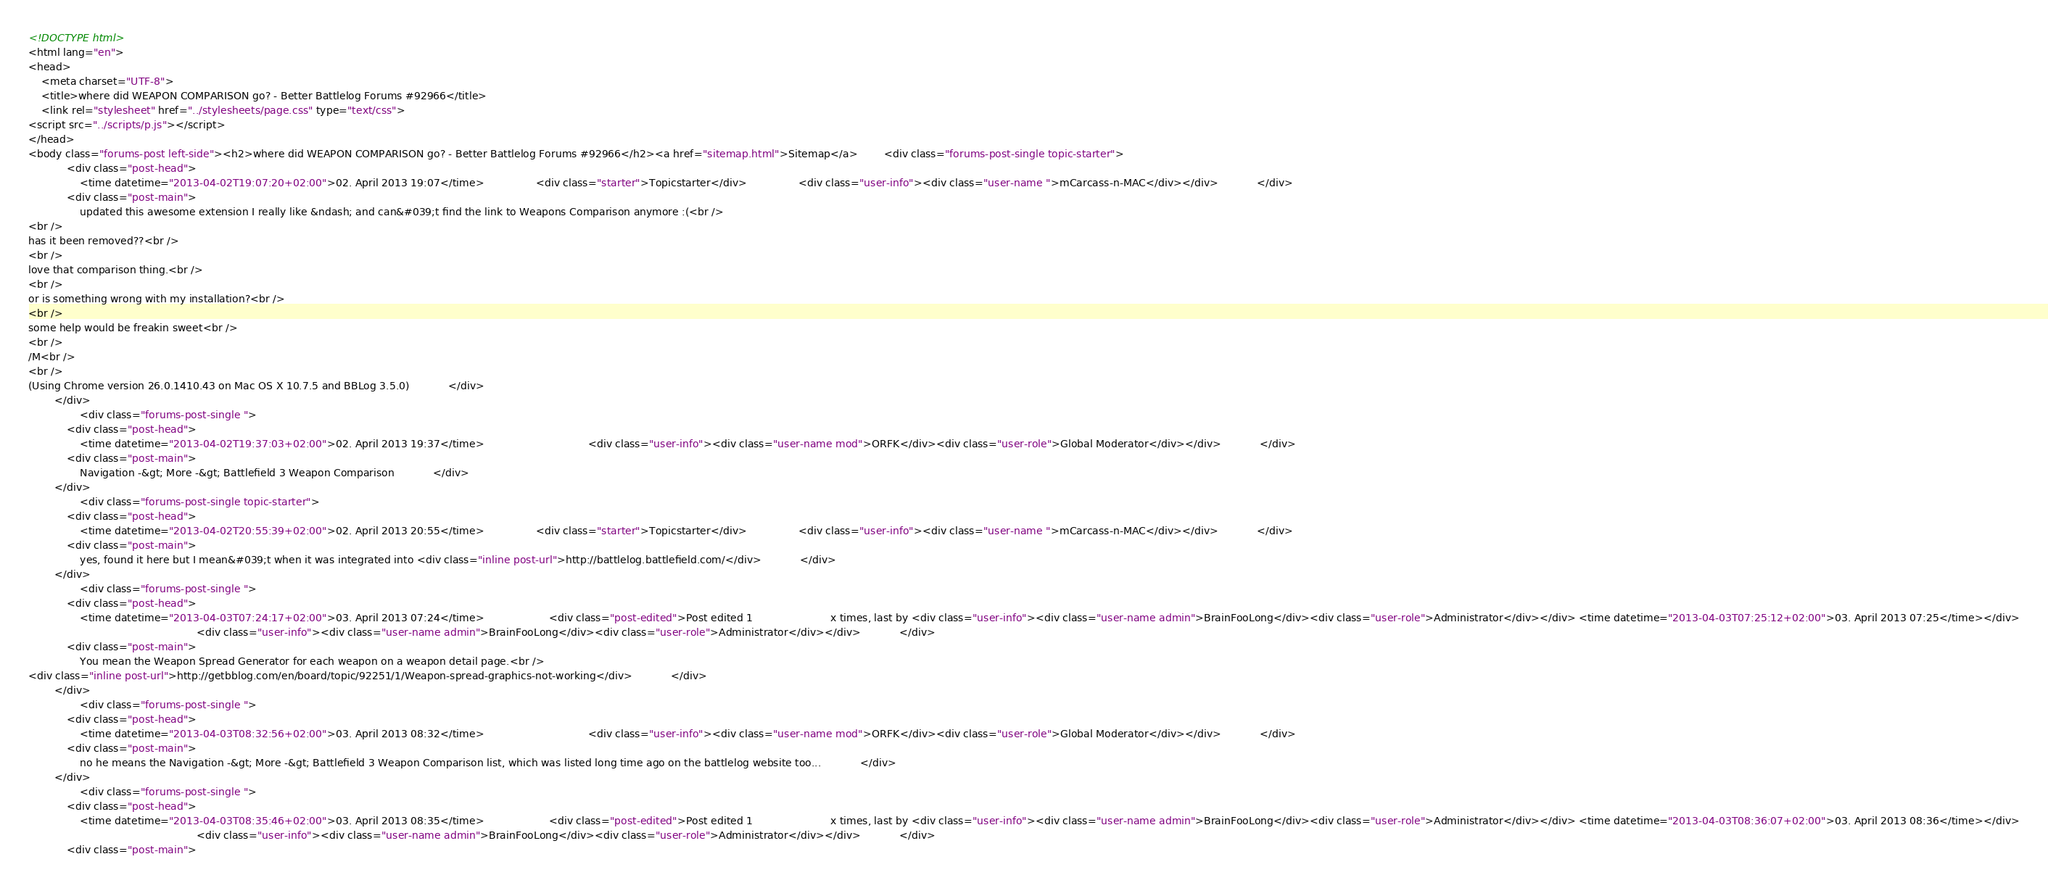Convert code to text. <code><loc_0><loc_0><loc_500><loc_500><_HTML_><!DOCTYPE html>
<html lang="en">
<head>
    <meta charset="UTF-8">
    <title>where did WEAPON COMPARISON go? - Better Battlelog Forums #92966</title>
    <link rel="stylesheet" href="../stylesheets/page.css" type="text/css">
<script src="../scripts/p.js"></script>
</head>
<body class="forums-post left-side"><h2>where did WEAPON COMPARISON go? - Better Battlelog Forums #92966</h2><a href="sitemap.html">Sitemap</a>        <div class="forums-post-single topic-starter">
            <div class="post-head">
                <time datetime="2013-04-02T19:07:20+02:00">02. April 2013 19:07</time>                <div class="starter">Topicstarter</div>                <div class="user-info"><div class="user-name ">mCarcass-n-MAC</div></div>            </div>
            <div class="post-main">
                updated this awesome extension I really like &ndash; and can&#039;t find the link to Weapons Comparison anymore :(<br />
<br />
has it been removed??<br />
<br />
love that comparison thing.<br />
<br />
or is something wrong with my installation?<br />
<br />
some help would be freakin sweet<br />
<br />
/M<br />
<br />
(Using Chrome version 26.0.1410.43 on Mac OS X 10.7.5 and BBLog 3.5.0)            </div>
        </div>
                <div class="forums-post-single ">
            <div class="post-head">
                <time datetime="2013-04-02T19:37:03+02:00">02. April 2013 19:37</time>                                <div class="user-info"><div class="user-name mod">ORFK</div><div class="user-role">Global Moderator</div></div>            </div>
            <div class="post-main">
                Navigation -&gt; More -&gt; Battlefield 3 Weapon Comparison            </div>
        </div>
                <div class="forums-post-single topic-starter">
            <div class="post-head">
                <time datetime="2013-04-02T20:55:39+02:00">02. April 2013 20:55</time>                <div class="starter">Topicstarter</div>                <div class="user-info"><div class="user-name ">mCarcass-n-MAC</div></div>            </div>
            <div class="post-main">
                yes, found it here but I mean&#039;t when it was integrated into <div class="inline post-url">http://battlelog.battlefield.com/</div>            </div>
        </div>
                <div class="forums-post-single ">
            <div class="post-head">
                <time datetime="2013-04-03T07:24:17+02:00">03. April 2013 07:24</time>                    <div class="post-edited">Post edited 1                        x times, last by <div class="user-info"><div class="user-name admin">BrainFooLong</div><div class="user-role">Administrator</div></div> <time datetime="2013-04-03T07:25:12+02:00">03. April 2013 07:25</time></div>
                                                    <div class="user-info"><div class="user-name admin">BrainFooLong</div><div class="user-role">Administrator</div></div>            </div>
            <div class="post-main">
                You mean the Weapon Spread Generator for each weapon on a weapon detail page.<br />
<div class="inline post-url">http://getbblog.com/en/board/topic/92251/1/Weapon-spread-graphics-not-working</div>            </div>
        </div>
                <div class="forums-post-single ">
            <div class="post-head">
                <time datetime="2013-04-03T08:32:56+02:00">03. April 2013 08:32</time>                                <div class="user-info"><div class="user-name mod">ORFK</div><div class="user-role">Global Moderator</div></div>            </div>
            <div class="post-main">
                no he means the Navigation -&gt; More -&gt; Battlefield 3 Weapon Comparison list, which was listed long time ago on the battlelog website too...            </div>
        </div>
                <div class="forums-post-single ">
            <div class="post-head">
                <time datetime="2013-04-03T08:35:46+02:00">03. April 2013 08:35</time>                    <div class="post-edited">Post edited 1                        x times, last by <div class="user-info"><div class="user-name admin">BrainFooLong</div><div class="user-role">Administrator</div></div> <time datetime="2013-04-03T08:36:07+02:00">03. April 2013 08:36</time></div>
                                                    <div class="user-info"><div class="user-name admin">BrainFooLong</div><div class="user-role">Administrator</div></div>            </div>
            <div class="post-main"></code> 